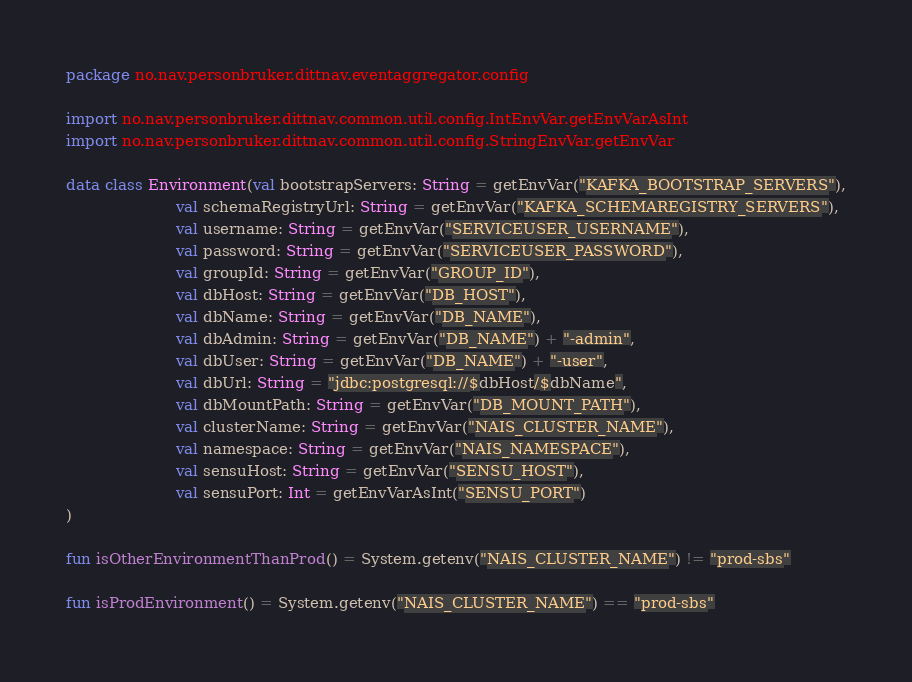Convert code to text. <code><loc_0><loc_0><loc_500><loc_500><_Kotlin_>package no.nav.personbruker.dittnav.eventaggregator.config

import no.nav.personbruker.dittnav.common.util.config.IntEnvVar.getEnvVarAsInt
import no.nav.personbruker.dittnav.common.util.config.StringEnvVar.getEnvVar

data class Environment(val bootstrapServers: String = getEnvVar("KAFKA_BOOTSTRAP_SERVERS"),
                       val schemaRegistryUrl: String = getEnvVar("KAFKA_SCHEMAREGISTRY_SERVERS"),
                       val username: String = getEnvVar("SERVICEUSER_USERNAME"),
                       val password: String = getEnvVar("SERVICEUSER_PASSWORD"),
                       val groupId: String = getEnvVar("GROUP_ID"),
                       val dbHost: String = getEnvVar("DB_HOST"),
                       val dbName: String = getEnvVar("DB_NAME"),
                       val dbAdmin: String = getEnvVar("DB_NAME") + "-admin",
                       val dbUser: String = getEnvVar("DB_NAME") + "-user",
                       val dbUrl: String = "jdbc:postgresql://$dbHost/$dbName",
                       val dbMountPath: String = getEnvVar("DB_MOUNT_PATH"),
                       val clusterName: String = getEnvVar("NAIS_CLUSTER_NAME"),
                       val namespace: String = getEnvVar("NAIS_NAMESPACE"),
                       val sensuHost: String = getEnvVar("SENSU_HOST"),
                       val sensuPort: Int = getEnvVarAsInt("SENSU_PORT")
)

fun isOtherEnvironmentThanProd() = System.getenv("NAIS_CLUSTER_NAME") != "prod-sbs"

fun isProdEnvironment() = System.getenv("NAIS_CLUSTER_NAME") == "prod-sbs"
</code> 